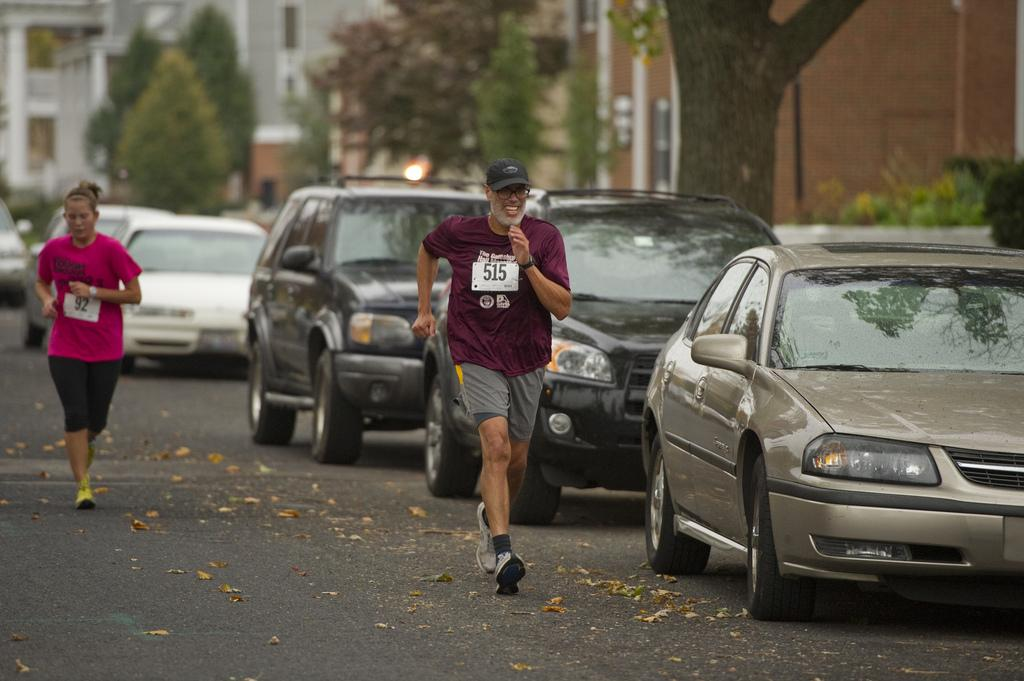How many people are present in the image? There are two people, a man and a woman, present in the image. What are the man and woman doing in the image? Both the man and woman are running on the road in the image. What can be seen in the background of the image? There are plants, a group of trees, and buildings visible in the image. Can you describe the bark of a tree in the image? The bark of a tree is visible in the image. What else can be seen on the side of the road in the image? There are cars parked on the side of the road in the image. What type of animal is the son holding in the image? There is no son or animal present in the image. How many ants can be seen crawling on the bark of the tree in the image? There are no ants visible on the bark of the tree in the image. 